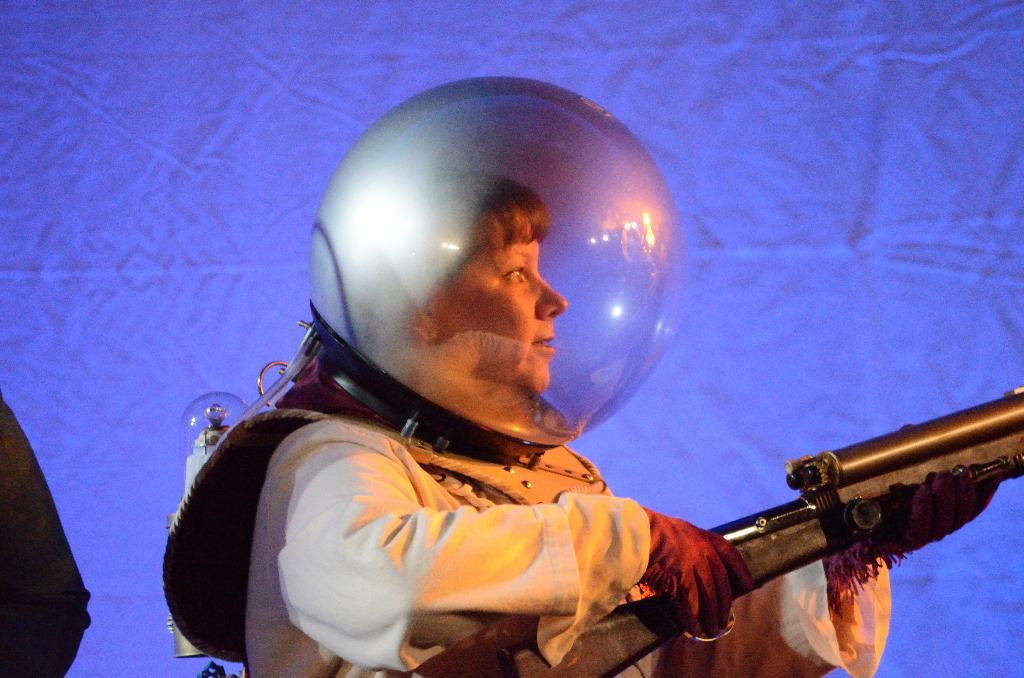What can be seen in the image related to a person? There is a person in the image. What is the person wearing? The person is wearing clothes and gloves. What object is the person holding in their hand? The person is holding a gun in their hand. What additional accessory is present in the image? There is a glass helmet in the image. What type of riddle is the person trying to solve in the image? There is no riddle present in the image; the person is holding a gun and wearing a glass helmet. Can you see a tiger in the image? No, there is no tiger present in the image. 